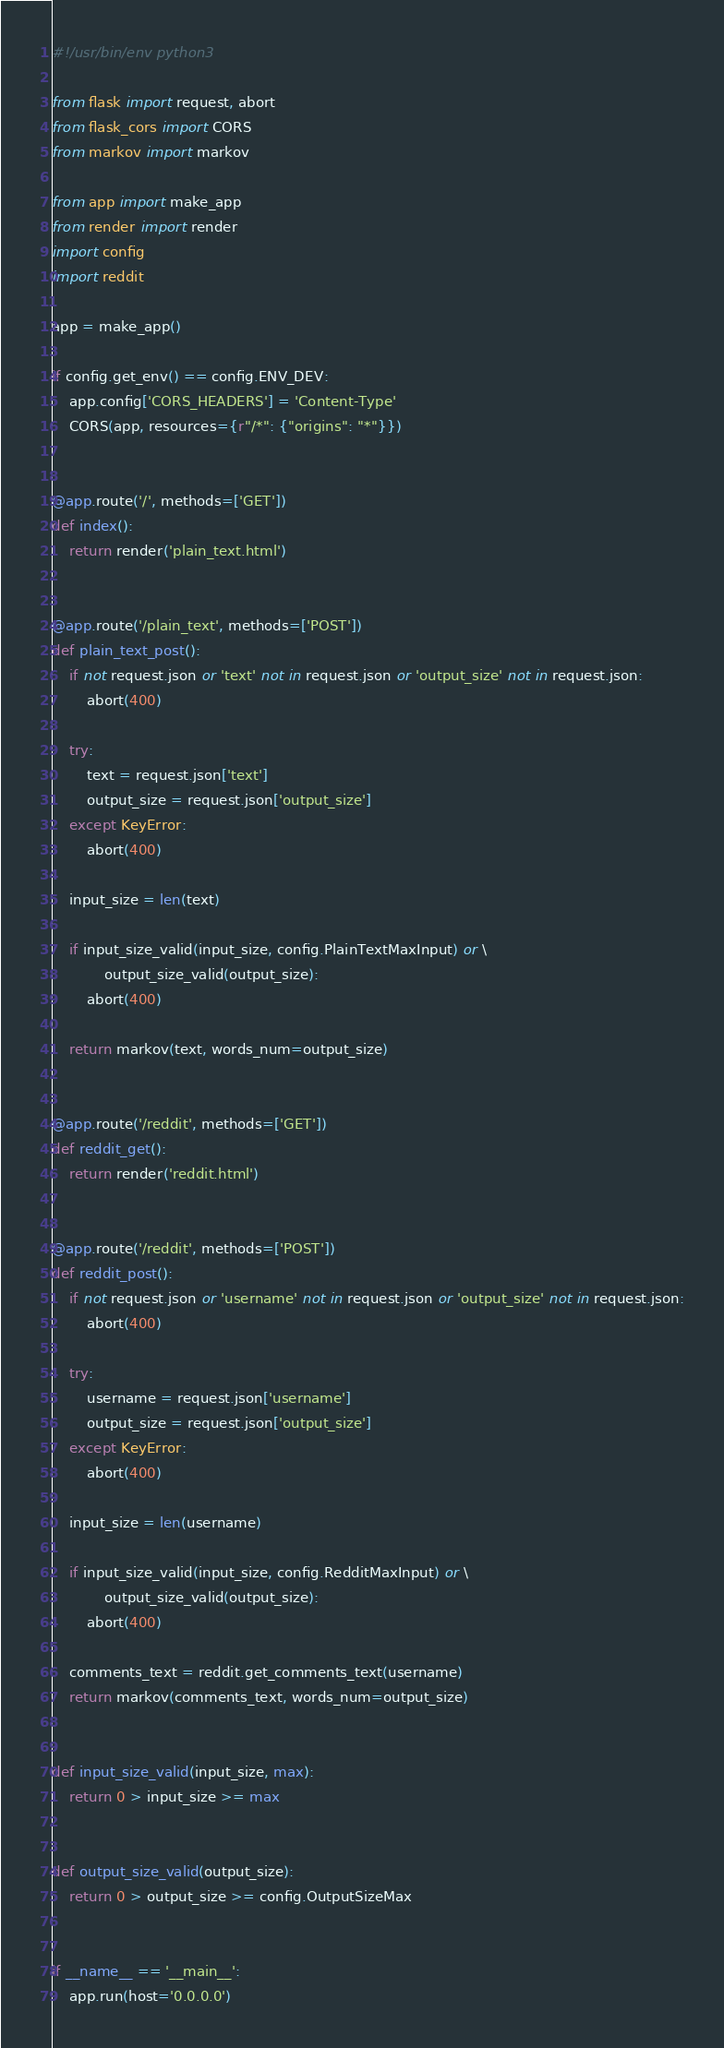<code> <loc_0><loc_0><loc_500><loc_500><_Python_>#!/usr/bin/env python3

from flask import request, abort
from flask_cors import CORS
from markov import markov

from app import make_app
from render import render
import config
import reddit

app = make_app()

if config.get_env() == config.ENV_DEV:
    app.config['CORS_HEADERS'] = 'Content-Type'
    CORS(app, resources={r"/*": {"origins": "*"}})


@app.route('/', methods=['GET'])
def index():
    return render('plain_text.html')


@app.route('/plain_text', methods=['POST'])
def plain_text_post():
    if not request.json or 'text' not in request.json or 'output_size' not in request.json:
        abort(400)

    try:
        text = request.json['text']
        output_size = request.json['output_size']
    except KeyError:
        abort(400)

    input_size = len(text)

    if input_size_valid(input_size, config.PlainTextMaxInput) or \
            output_size_valid(output_size):
        abort(400)

    return markov(text, words_num=output_size)


@app.route('/reddit', methods=['GET'])
def reddit_get():
    return render('reddit.html')


@app.route('/reddit', methods=['POST'])
def reddit_post():
    if not request.json or 'username' not in request.json or 'output_size' not in request.json:
        abort(400)

    try:
        username = request.json['username']
        output_size = request.json['output_size']
    except KeyError:
        abort(400)

    input_size = len(username)

    if input_size_valid(input_size, config.RedditMaxInput) or \
            output_size_valid(output_size):
        abort(400)

    comments_text = reddit.get_comments_text(username)
    return markov(comments_text, words_num=output_size)


def input_size_valid(input_size, max):
    return 0 > input_size >= max


def output_size_valid(output_size):
    return 0 > output_size >= config.OutputSizeMax


if __name__ == '__main__':
    app.run(host='0.0.0.0')
</code> 